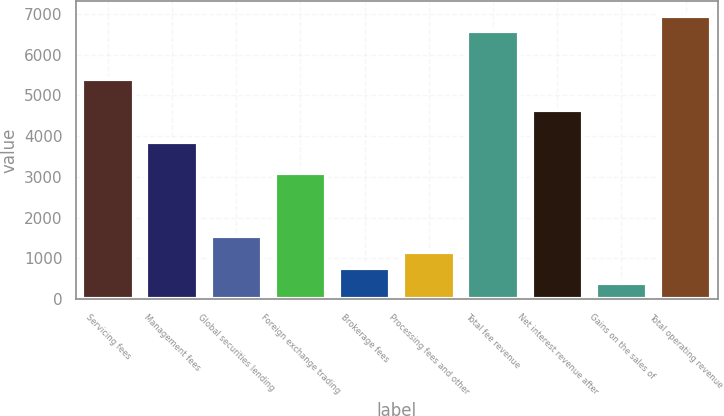<chart> <loc_0><loc_0><loc_500><loc_500><bar_chart><fcel>Servicing fees<fcel>Management fees<fcel>Global securities lending<fcel>Foreign exchange trading<fcel>Brokerage fees<fcel>Processing fees and other<fcel>Total fee revenue<fcel>Net interest revenue after<fcel>Gains on the sales of<fcel>Total operating revenue<nl><fcel>5414.28<fcel>3867.96<fcel>1548.48<fcel>3094.8<fcel>775.32<fcel>1161.9<fcel>6574.02<fcel>4641.12<fcel>388.74<fcel>6960.6<nl></chart> 